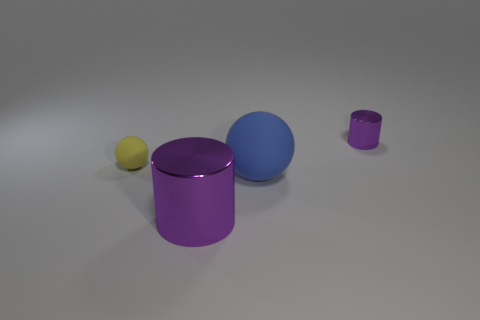The ball on the right side of the cylinder that is in front of the large rubber object is what color?
Keep it short and to the point. Blue. What is the size of the object that is the same color as the small cylinder?
Offer a very short reply. Large. There is a shiny cylinder on the right side of the shiny cylinder in front of the small purple metallic object; what number of tiny matte things are on the right side of it?
Ensure brevity in your answer.  0. Do the big thing that is behind the big shiny thing and the shiny object that is on the right side of the big blue matte ball have the same shape?
Make the answer very short. No. How many things are either metal objects or large blue metallic balls?
Give a very brief answer. 2. There is a purple cylinder that is in front of the purple cylinder that is right of the large shiny cylinder; what is its material?
Offer a very short reply. Metal. Are there any other things of the same color as the big metallic object?
Offer a very short reply. Yes. What color is the cylinder that is the same size as the blue thing?
Offer a terse response. Purple. There is a small cylinder that is behind the matte thing that is in front of the rubber thing on the left side of the large blue matte sphere; what is its material?
Ensure brevity in your answer.  Metal. There is a big cylinder; is it the same color as the rubber object to the right of the large metal cylinder?
Your response must be concise. No. 